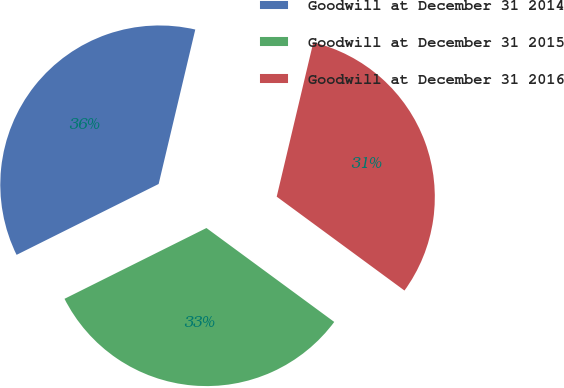<chart> <loc_0><loc_0><loc_500><loc_500><pie_chart><fcel>Goodwill at December 31 2014<fcel>Goodwill at December 31 2015<fcel>Goodwill at December 31 2016<nl><fcel>36.07%<fcel>32.55%<fcel>31.38%<nl></chart> 